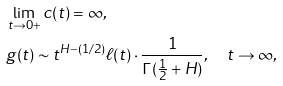<formula> <loc_0><loc_0><loc_500><loc_500>& \lim _ { t \to 0 + } c ( t ) = \infty , \\ & g ( t ) \sim t ^ { H - ( 1 / 2 ) } \ell ( t ) \cdot \frac { 1 } { \Gamma ( \frac { 1 } { 2 } + H ) } , \quad t \to \infty ,</formula> 